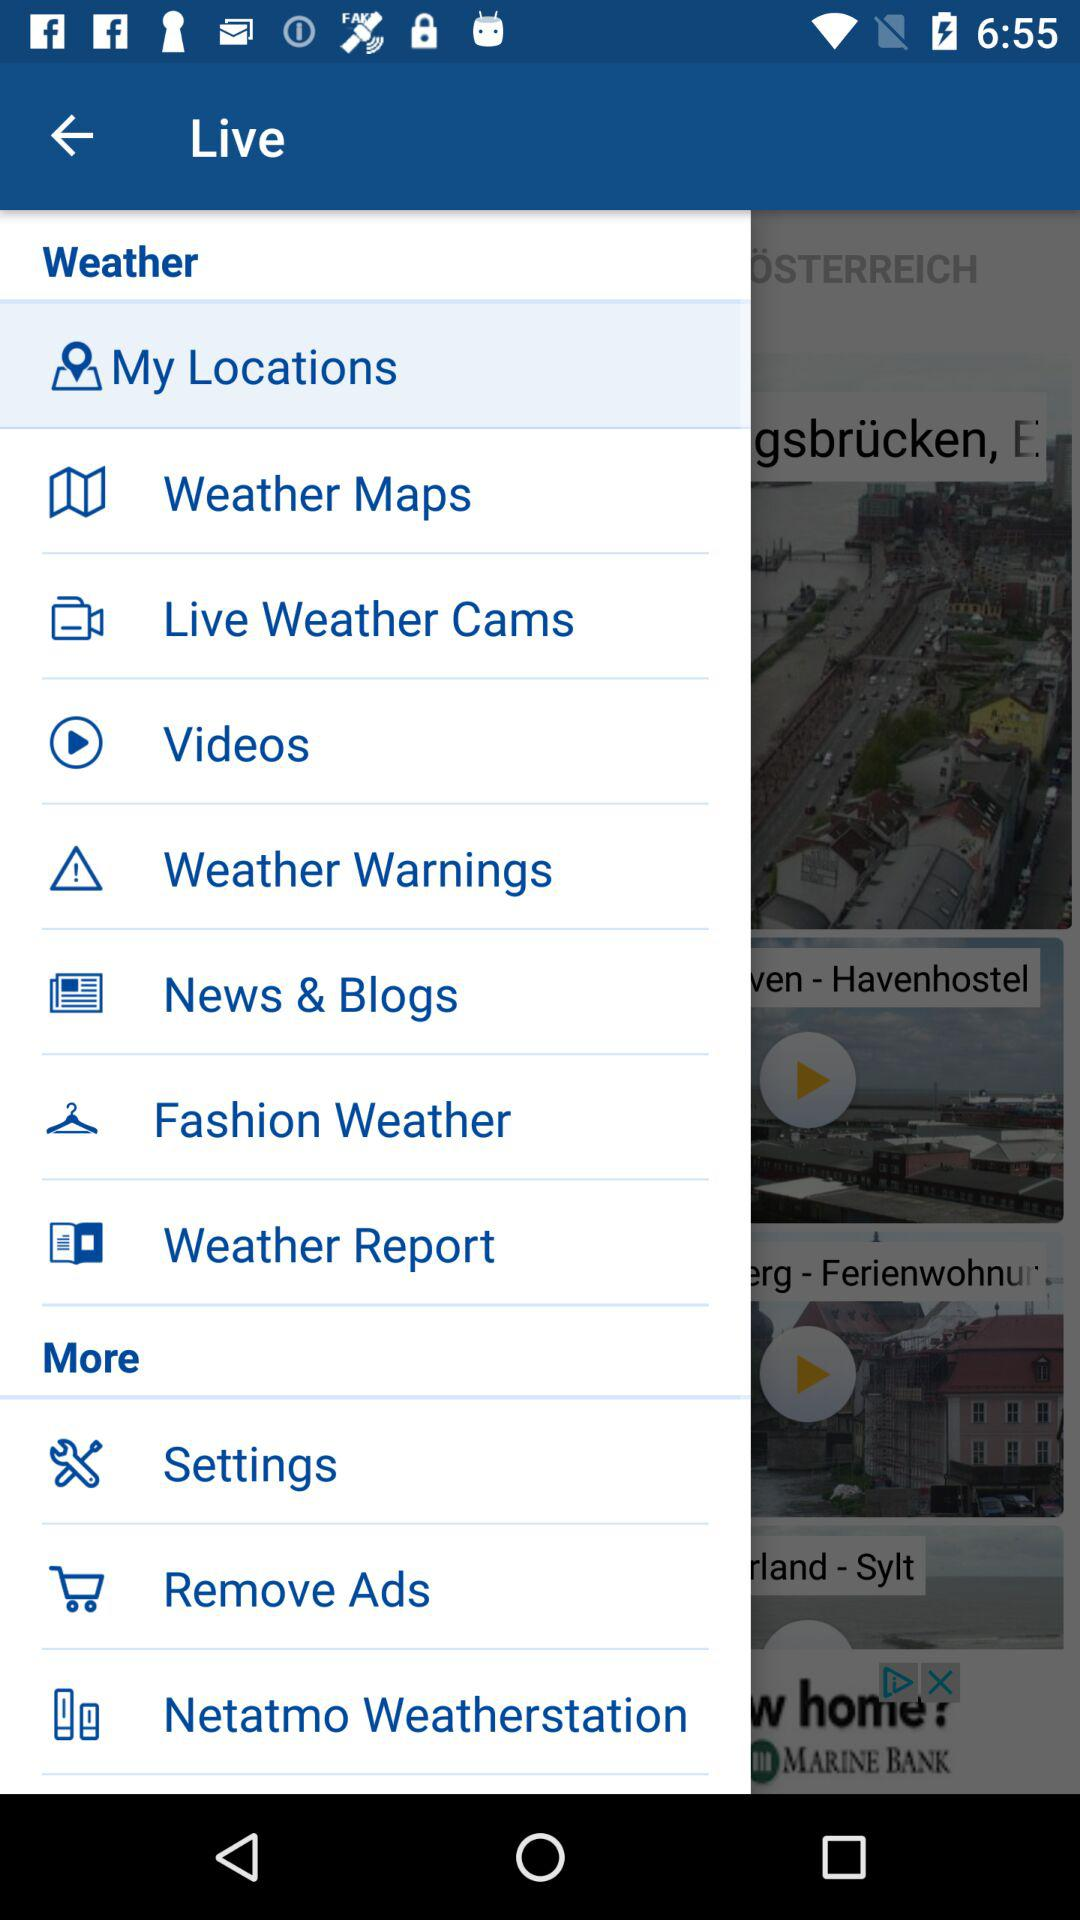Which item is highlighted? The highlighted item is "My Locations". 